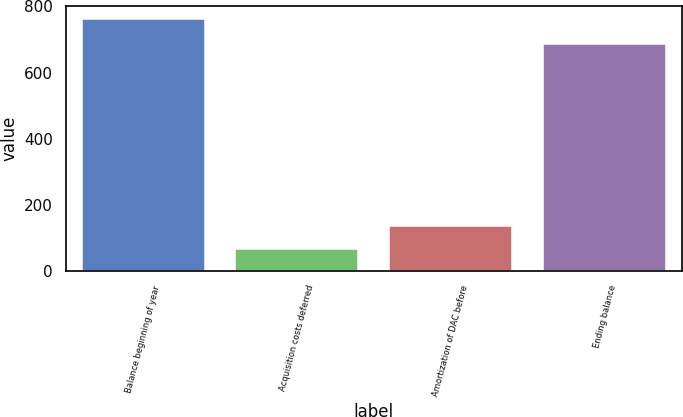Convert chart. <chart><loc_0><loc_0><loc_500><loc_500><bar_chart><fcel>Balance beginning of year<fcel>Acquisition costs deferred<fcel>Amortization of DAC before<fcel>Ending balance<nl><fcel>762<fcel>66<fcel>135.6<fcel>687<nl></chart> 